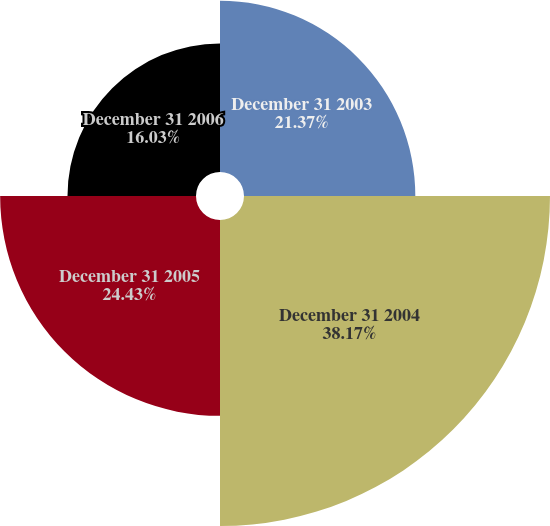<chart> <loc_0><loc_0><loc_500><loc_500><pie_chart><fcel>December 31 2003<fcel>December 31 2004<fcel>December 31 2005<fcel>December 31 2006<nl><fcel>21.37%<fcel>38.17%<fcel>24.43%<fcel>16.03%<nl></chart> 